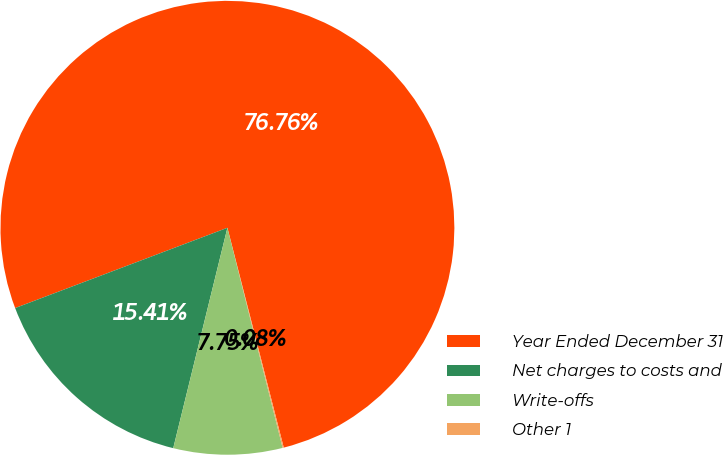<chart> <loc_0><loc_0><loc_500><loc_500><pie_chart><fcel>Year Ended December 31<fcel>Net charges to costs and<fcel>Write-offs<fcel>Other 1<nl><fcel>76.76%<fcel>15.41%<fcel>7.75%<fcel>0.08%<nl></chart> 